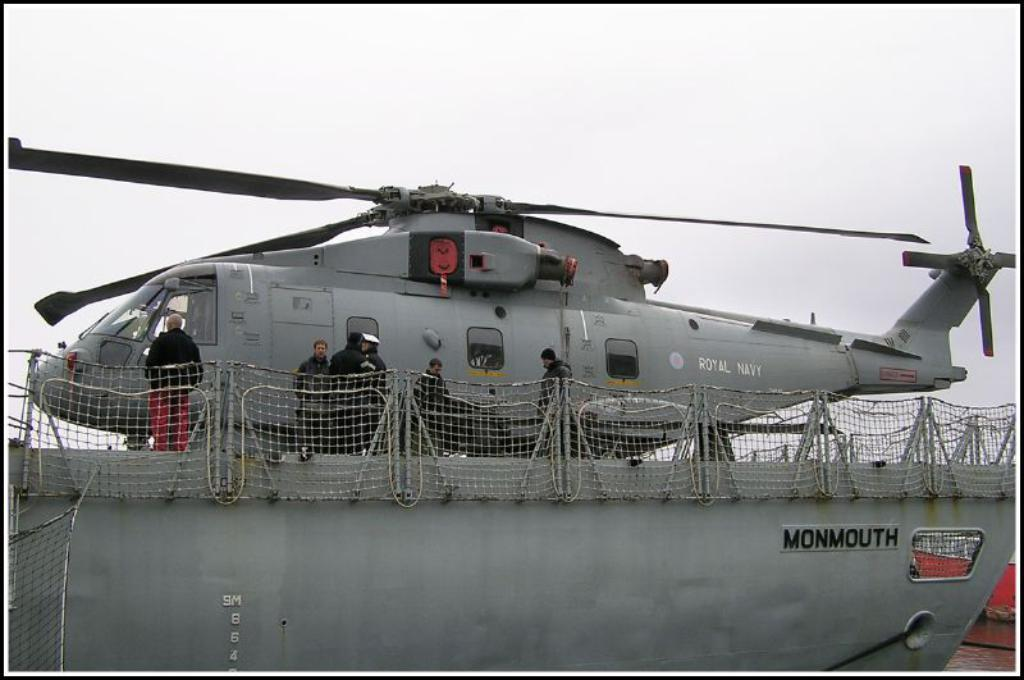<image>
Create a compact narrative representing the image presented. A helicopter on a ship that says Royal Navy on it 